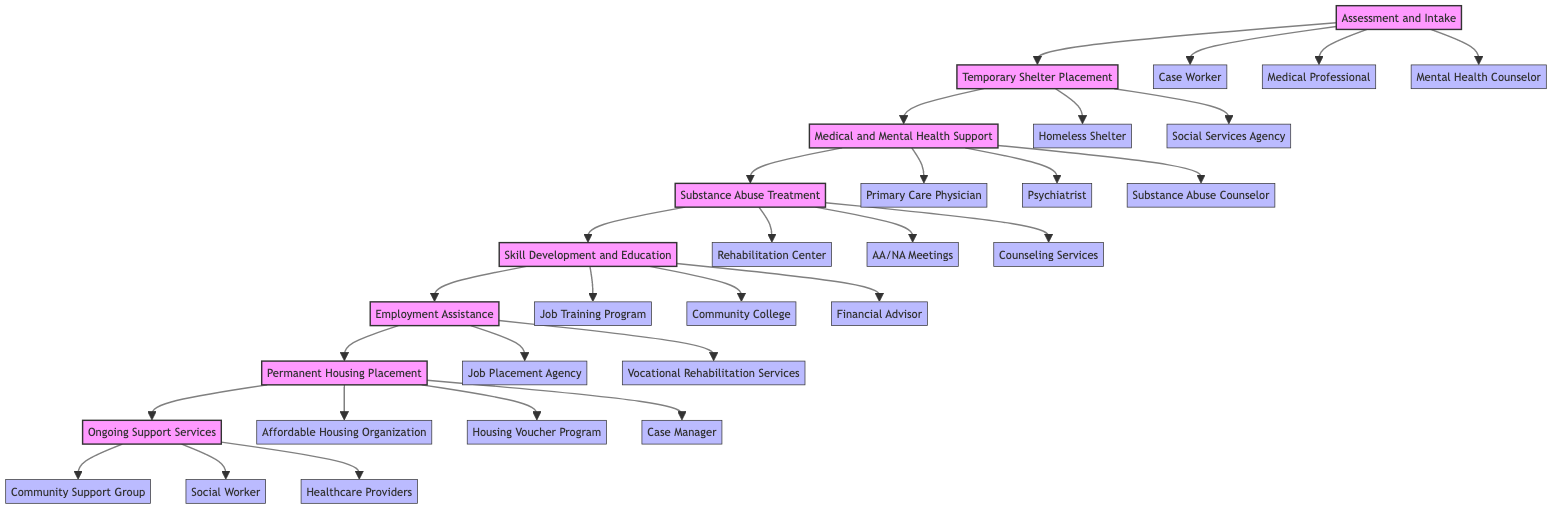What is the first step in the transition process? The first step is "Assessment and Intake" as identified at the beginning of the flowchart.
Answer: Assessment and Intake How many steps are there in total? By counting the nodes in the flowchart, there are eight distinct steps in the transitioning process.
Answer: 8 What follows after "Temporary Shelter Placement"? The step that follows "Temporary Shelter Placement" is "Medical and Mental Health Support", as indicated by the directed arrow in the flowchart.
Answer: Medical and Mental Health Support Which entities are involved in the "Substance Abuse Treatment"? The entities listed under "Substance Abuse Treatment" are "Rehabilitation Center", "AA/NA Meetings", and "Counseling Services" as shown in the diagram.
Answer: Rehabilitation Center, AA/NA Meetings, Counseling Services What is the final step in the flowchart? The final step listed at the end of the flowchart is "Ongoing Support Services" which emphasizes the continuous nature of support required after transitioning to independent living.
Answer: Ongoing Support Services Which step requires skill development and education? The step named "Skill Development and Education" clearly states that this process focuses on training for job skills and financial literacy, succeeding "Substance Abuse Treatment".
Answer: Skill Development and Education How many entities are involved in the "Assessment and Intake" step? Three entities are involved in the "Assessment and Intake" step: "Case Worker", "Medical Professional", and "Mental Health Counselor", as enumerated in the diagram.
Answer: 3 Which step comes directly before the "Permanent Housing Placement"? The step that precedes "Permanent Housing Placement" in the flowchart is "Employment Assistance", indicating a logical progression towards securing housing after obtaining employment.
Answer: Employment Assistance What type of support is provided in the last step? The last step "Ongoing Support Services" emphasizes continuous support for maintaining independent living, which is crucial for long-term success.
Answer: Continuous support for maintaining independent living 